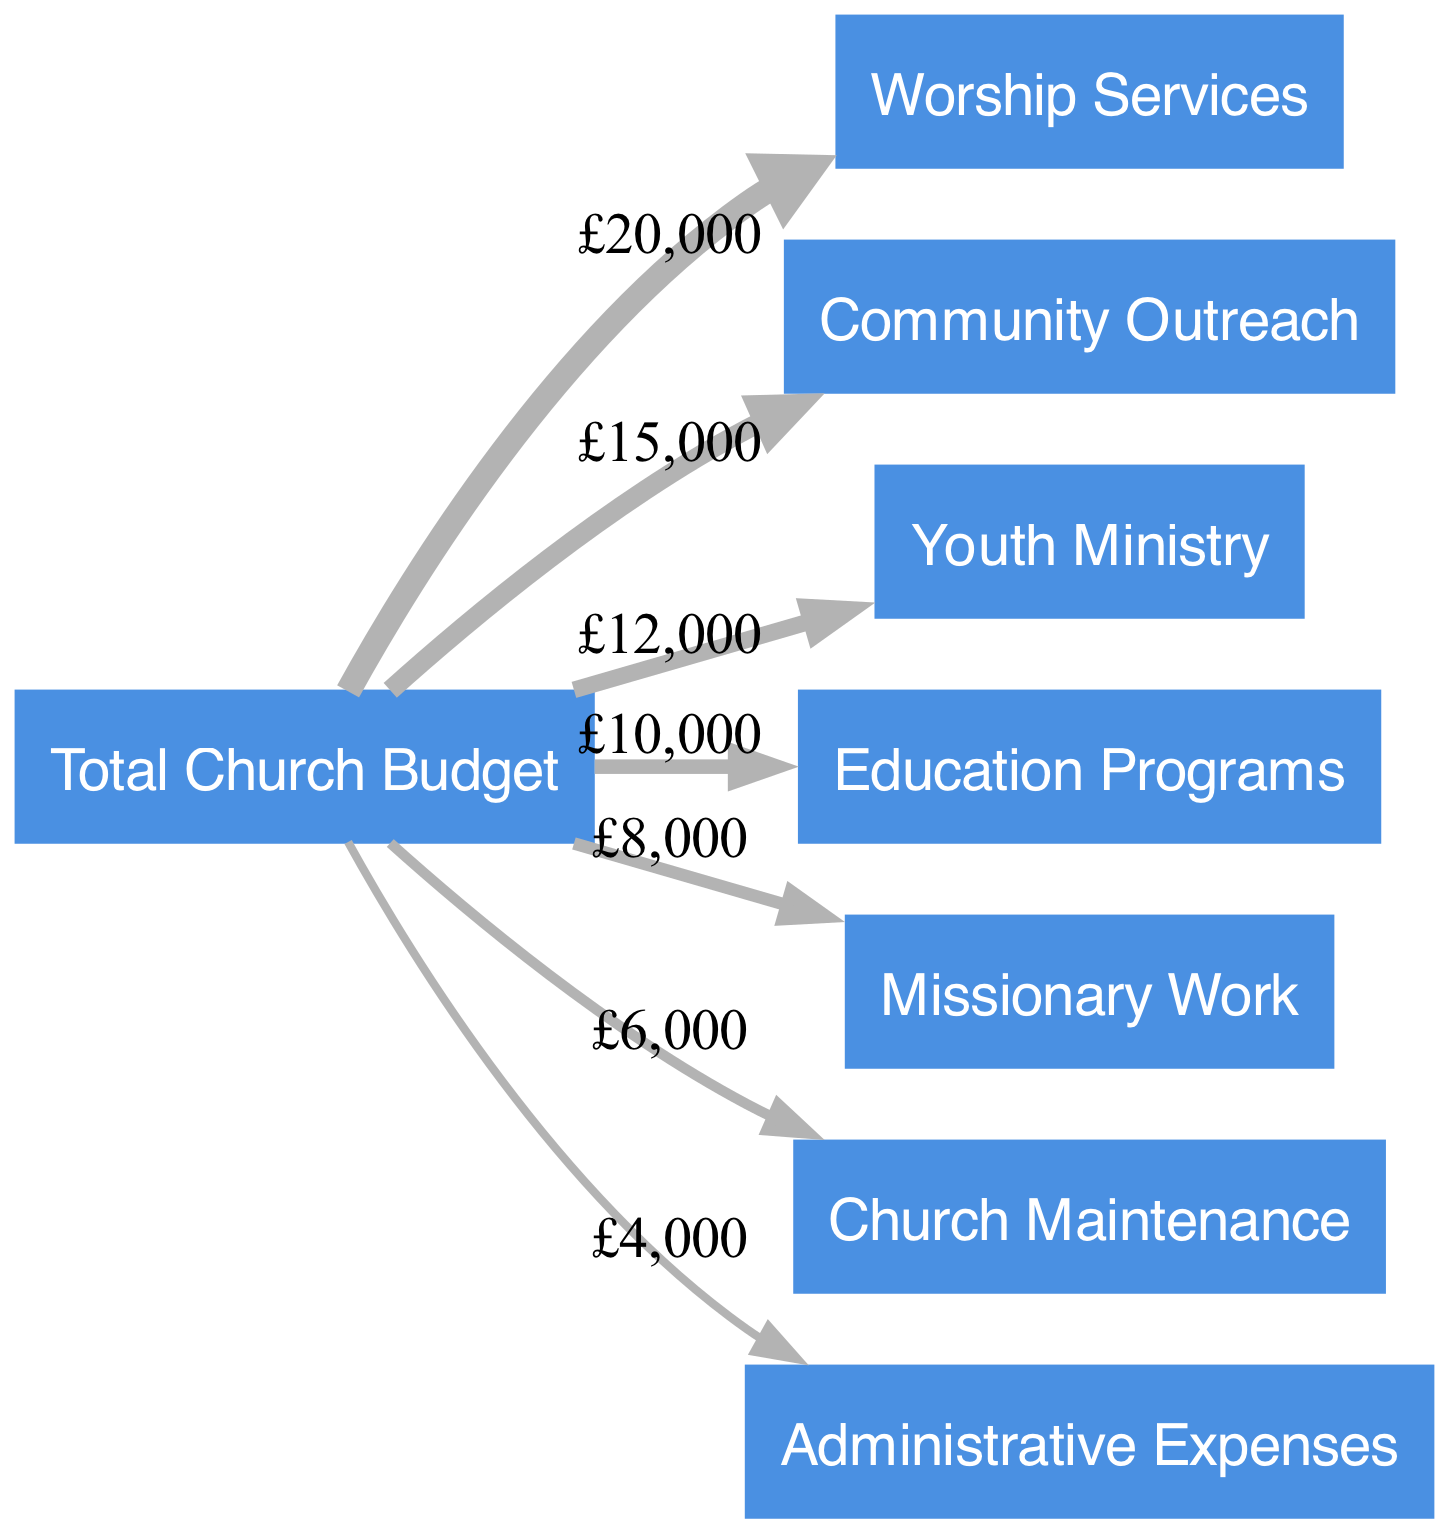What is the total church budget? The diagram indicates the allocation begins with the total church budget node. This node represents the overall budget amount and encompasses all subsequent expenditures listed. Thus, the answer is derived directly from the total budget, which is represented as a single entity.
Answer: 100000 How much is allocated to Worship Services? By examining the link between "Total Church Budget" and "Worship Services," we can see that a specified value is indicated. The width of the link corresponds to the amount allocated to this particular ministry, so that value is directly discerned from the diagram.
Answer: 20000 Which ministry receives the least funding? To identify the ministry with the least funding, we evaluate the values associated with each link emanating from "Total Church Budget." By comparing these values, we find that the smallest amount allocated corresponds to the link with the lowest width. Thus, we analyze the corresponding node to get the answer.
Answer: Administrative Expenses What is the total amount allocated for Community Outreach and Youth Ministry combined? This requires us to consider the links for both "Community Outreach" and "Youth Ministry." We first extract the amounts allocated to each ministry from their respective links. Then we sum these amounts to find the combined allocation, exemplifying the relationship between multiple nodes through their values.
Answer: 27000 How many ministries are funded in total? Counting the number of distinct nodes that receive funding after the "Total Church Budget" node will yield the answer. Each node linked from the budget can be categorized as a ministry or program, so we simply count these nodes to determine the total number of ministries receiving funding.
Answer: 7 Which ministry has the highest funding after Worship Services? We first identify the ministry with the highest funding using the link for "Worship Services." After noting this value, we look at all other links and find the next highest value to determine which ministry comes next in funding order, hence establishing a comparative relationship among nodes.
Answer: Community Outreach How much is designated for Church Maintenance? By locating the specific link connected to the "Church Maintenance" node, we can read the corresponding value along the link. This value reflects the direct allocation made for this area, thus answering the query.
Answer: 6000 